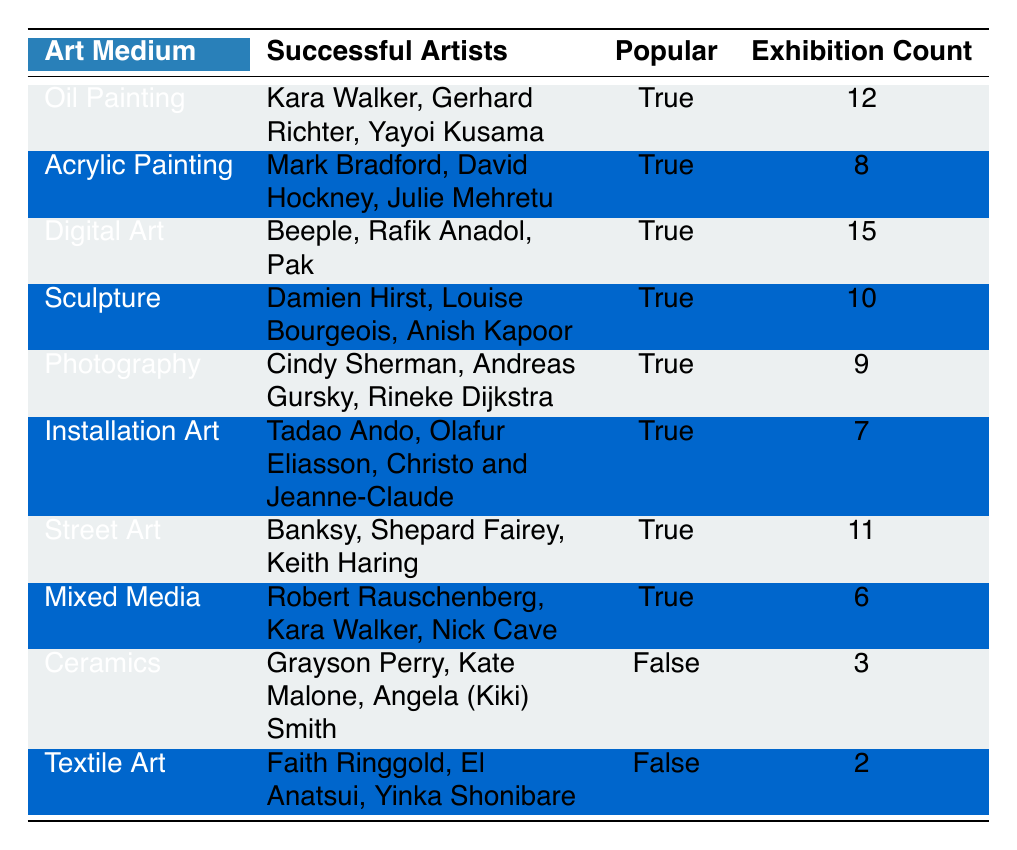What is the most popular art medium based on the number of exhibitions? Digital Art has the highest exhibition count at 15, compared to all other mediums listed.
Answer: Digital Art How many successful artists are associated with Sculpture? Sculpture lists three successful artists: Damien Hirst, Louise Bourgeois, and Anish Kapoor.
Answer: 3 Is Textile Art considered a popular medium? Textile Art is labeled as false for popularity in the table, indicating it is not considered popular.
Answer: No Which medium has the least number of exhibitions? Ceramics has the lowest exhibition count at 3, making it the medium with the least exhibitions.
Answer: Ceramics What is the combined exhibition count of Mixed Media and Installation Art? Mixed Media has 6 exhibitions and Installation Art has 7 exhibitions. Adding these gives: 6 + 7 = 13.
Answer: 13 Is there any art medium listed that has a higher exhibition count than the number of successful artists associated with it? Yes, Digital Art has 15 exhibitions, which is higher than the 3 successful artists associated with it.
Answer: Yes What mediums have successful artists who are also shared across categories? Oil Painting and Mixed Media both have Kara Walker as a successful artist, indicating overlap in artists between mediums.
Answer: Oil Painting and Mixed Media How many mediums listed are popular? Counting the rows with 'True' under the Popular column, there are 8 mediums considered popular.
Answer: 8 Which medium has the highest number of successful artists but is not popular? Ceramics has three successful artists—Grayson Perry, Kate Malone, and Angela (Kiki) Smith—but it is not considered popular.
Answer: Ceramics 